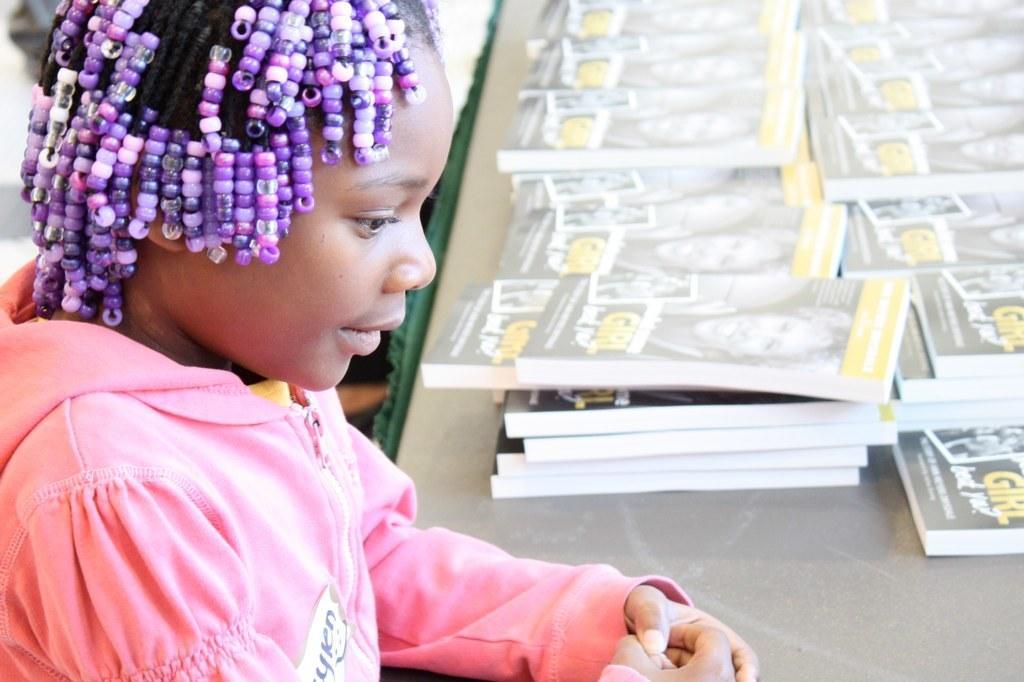Could you give a brief overview of what you see in this image? On the left side of the image there is a girl. In front of her there is a table. On top of the table there are books. 